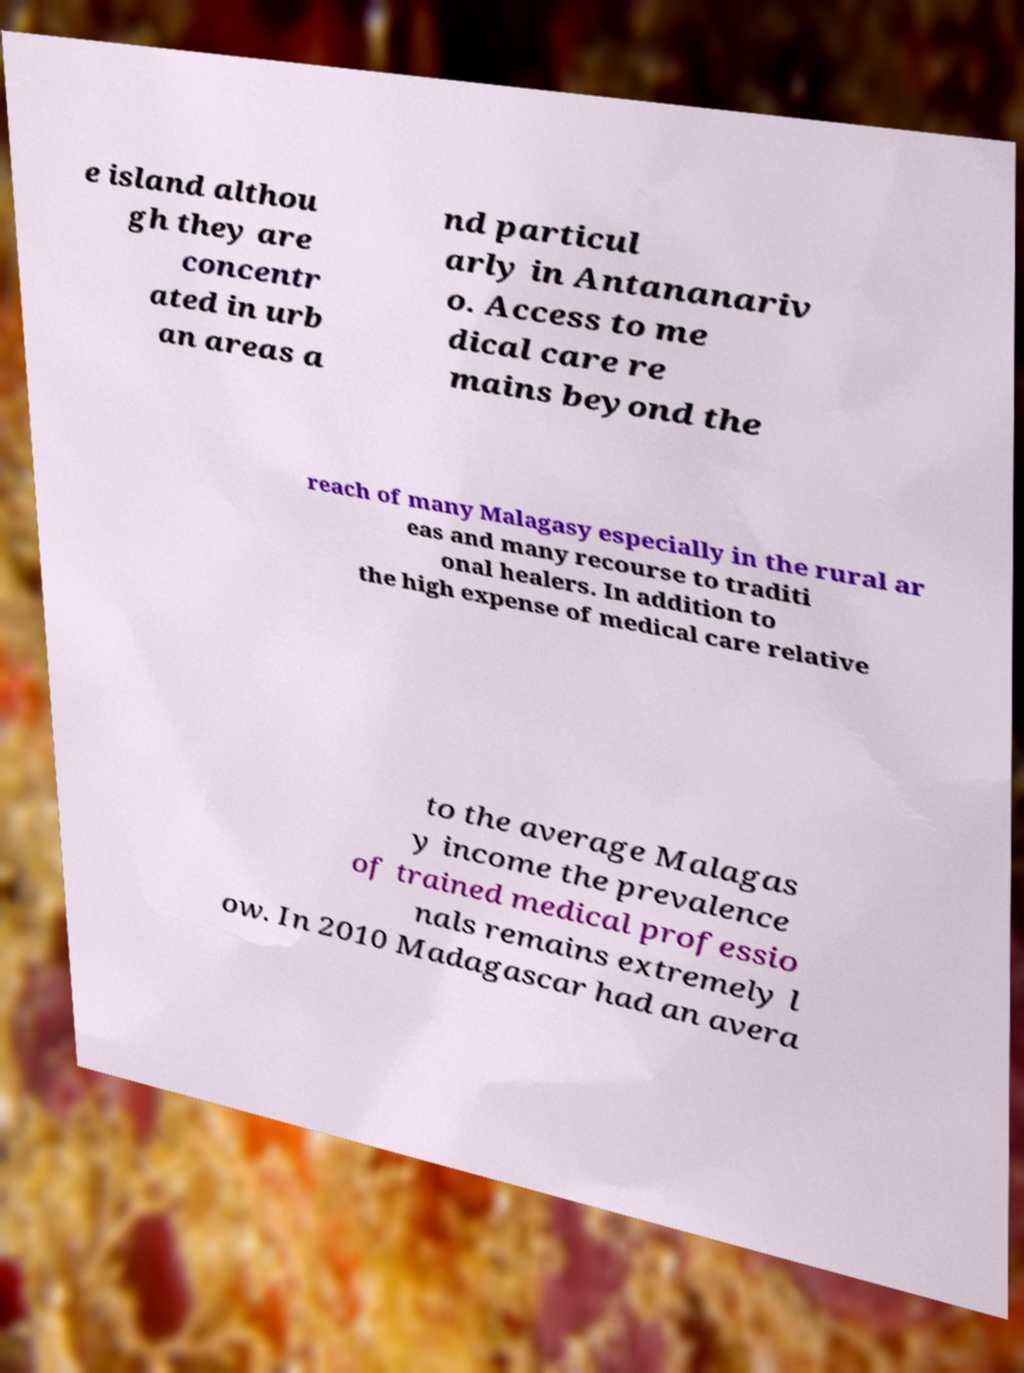Could you extract and type out the text from this image? e island althou gh they are concentr ated in urb an areas a nd particul arly in Antananariv o. Access to me dical care re mains beyond the reach of many Malagasy especially in the rural ar eas and many recourse to traditi onal healers. In addition to the high expense of medical care relative to the average Malagas y income the prevalence of trained medical professio nals remains extremely l ow. In 2010 Madagascar had an avera 